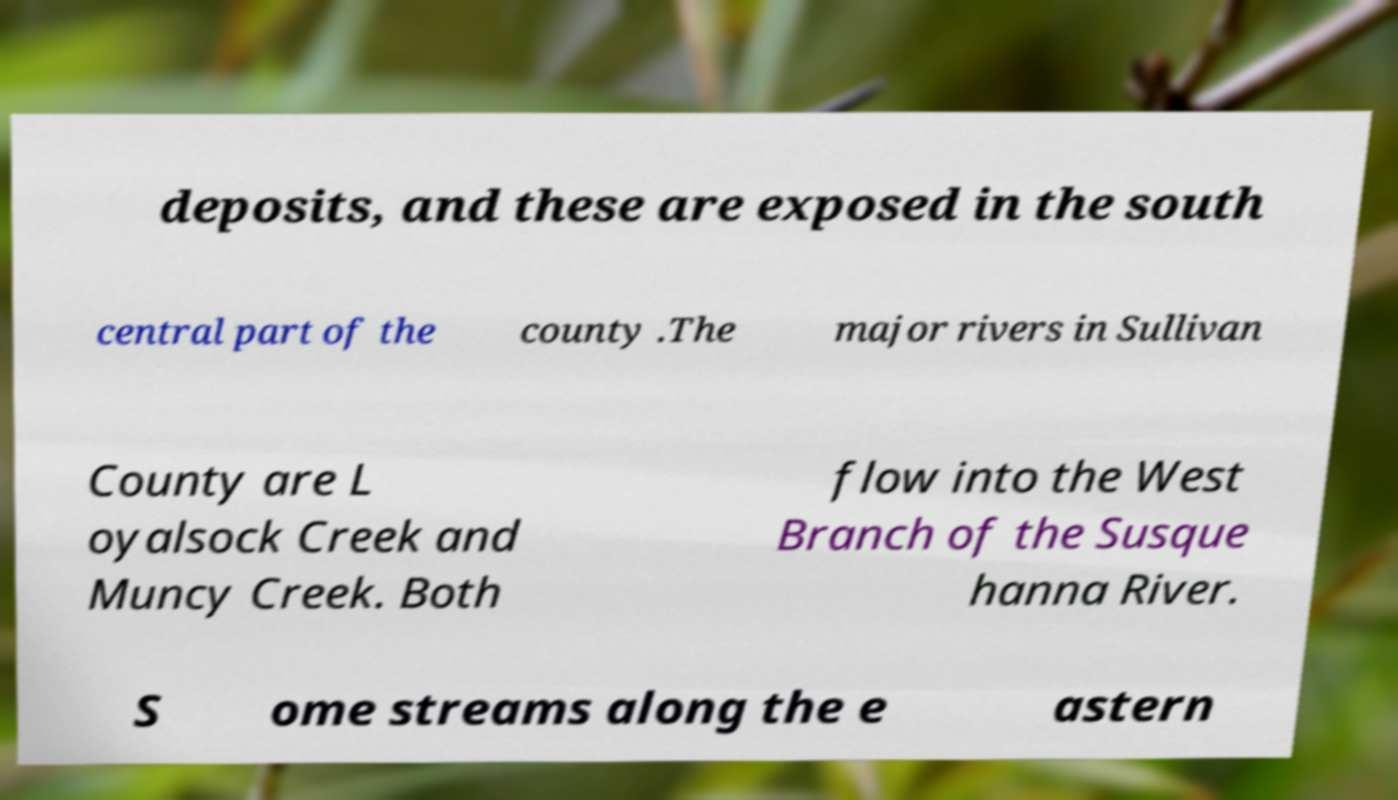Could you extract and type out the text from this image? deposits, and these are exposed in the south central part of the county .The major rivers in Sullivan County are L oyalsock Creek and Muncy Creek. Both flow into the West Branch of the Susque hanna River. S ome streams along the e astern 